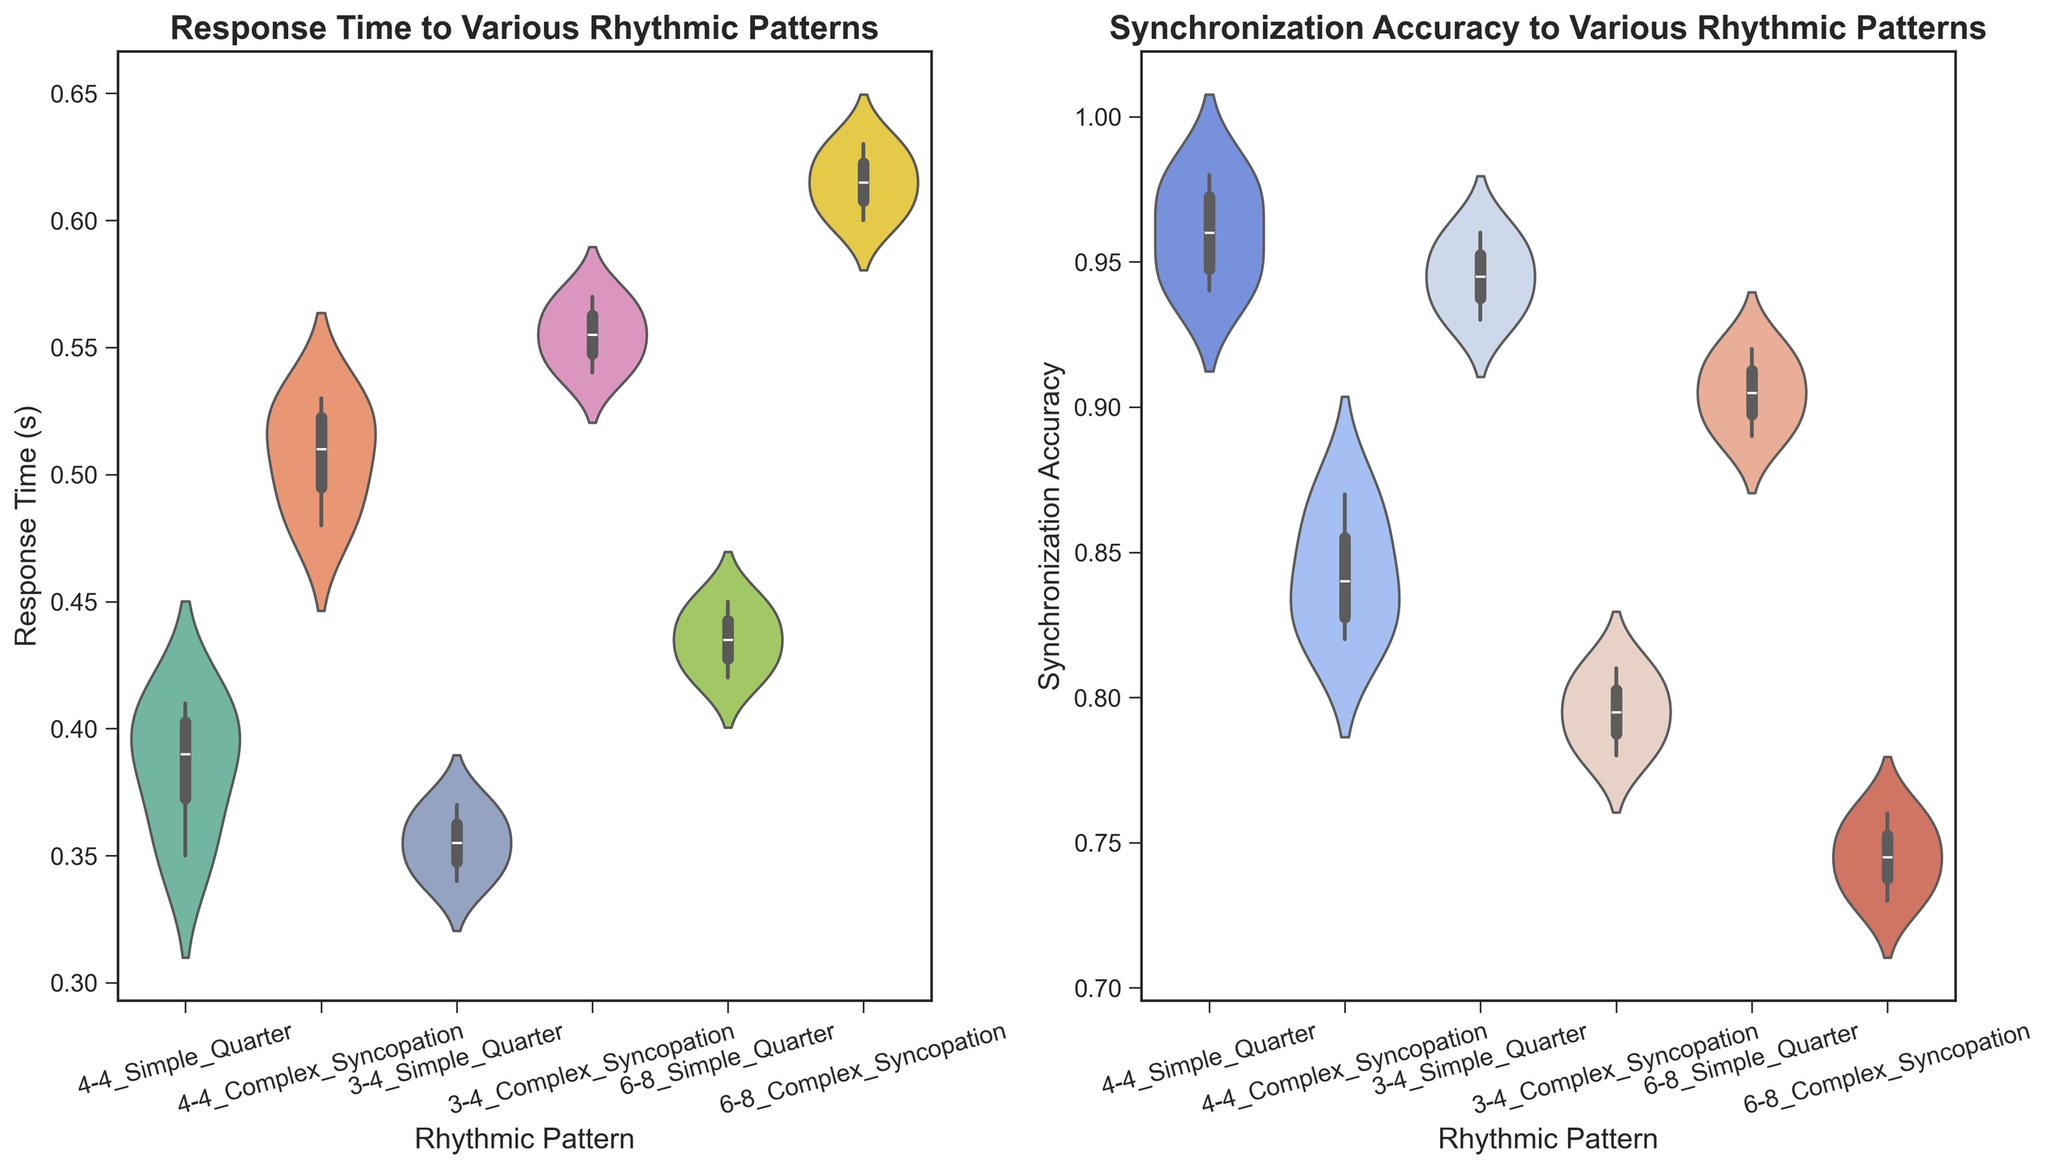What is the median response time for the rhythmic pattern "4-4 Simple Quarter"? The median is the central value when data points are ordered. In the figure, we can see that "4-4 Simple Quarter" has lower values centered around the middle. Looking at the plot, the median appears to be around 0.39 seconds.
Answer: 0.39 seconds What is the average synchronization accuracy for the "6-8 Complex Syncopation" rhythmic pattern? To find the average, look at the center of the violin plot for "6-8 Complex Syncopation". This plot shows values between 0.73 and 0.76, suggesting the average is 0.74 + 0.75 + 0.76/3 ≈ 0.74.
Answer: 0.74 Which rhythmic pattern has the highest response time and what is that time approximately? Look at the maximum values for each violin plot. The "6-8 Complex Syncopation" plot is the highest and appears to peak around 0.63 seconds.
Answer: 6-8 Complex Syncopation, 0.63 seconds For which rhythmic pattern is the synchronization accuracy spread the widest? The width of the "6-8 Complex Syncopation" violin plot for Sync Accuracy is the broadest, indicating a wider spread of data points around the median.
Answer: 6-8 Complex Syncopation Compare the median synchronization accuracy between "3-4 Simple Quarter" and "3-4 Complex Syncopation". Which one is higher? The medians are the center lines of the violin plots. "3-4 Simple Quarter" has its median around 0.94, while "3-4 Complex Syncopation" has it around 0.80.
Answer: 3-4 Simple Quarter How does the response time for "4-4 Complex Syncopation" compare to "4-4 Simple Quarter"? By comparing violin plots, we see "4-4 Complex Syncopation" has higher values concentrated around 0.50 seconds versus "4-4 Simple Quarter" around 0.39 seconds.
Answer: 4-4 Complex Syncopation is higher What is the approximate range of synchronization accuracy for "4-4 Simple Quarter"? The range is the difference between max and min values in the plot. The violin plot for "4-4 Simple Quarter" ranges from about 0.94 to 0.98. Thus, 0.98 - 0.94 = 0.04.
Answer: 0.04 Which rhythmic pattern has the narrowest range of synchronization accuracy? Check the tightest violin plot in the Sync Accuracy graph. "4-4 Simple Quarter" shows the least spread with a very narrow width.
Answer: 4-4 Simple Quarter Among all patterns, which one shows a lower median in synchronization accuracy: "3-4 Complex Syncopation" or "6-8 Simple Quarter"? Comparing medians of synchronization accuracy violin plots shows "3-4 Complex Syncopation" around 0.79 and "6-8 Simple Quarter" around 0.90.
Answer: 3-4 Complex Syncopation 